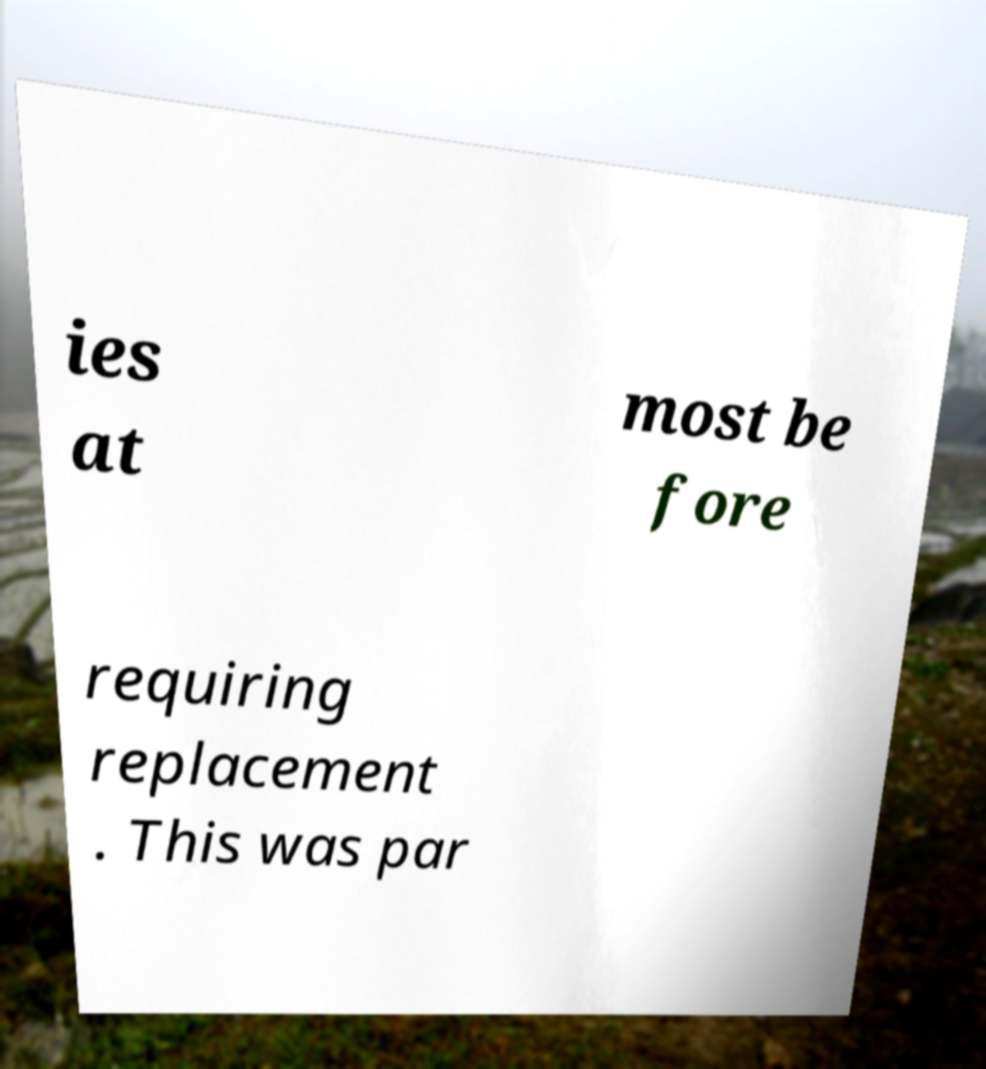Could you extract and type out the text from this image? ies at most be fore requiring replacement . This was par 